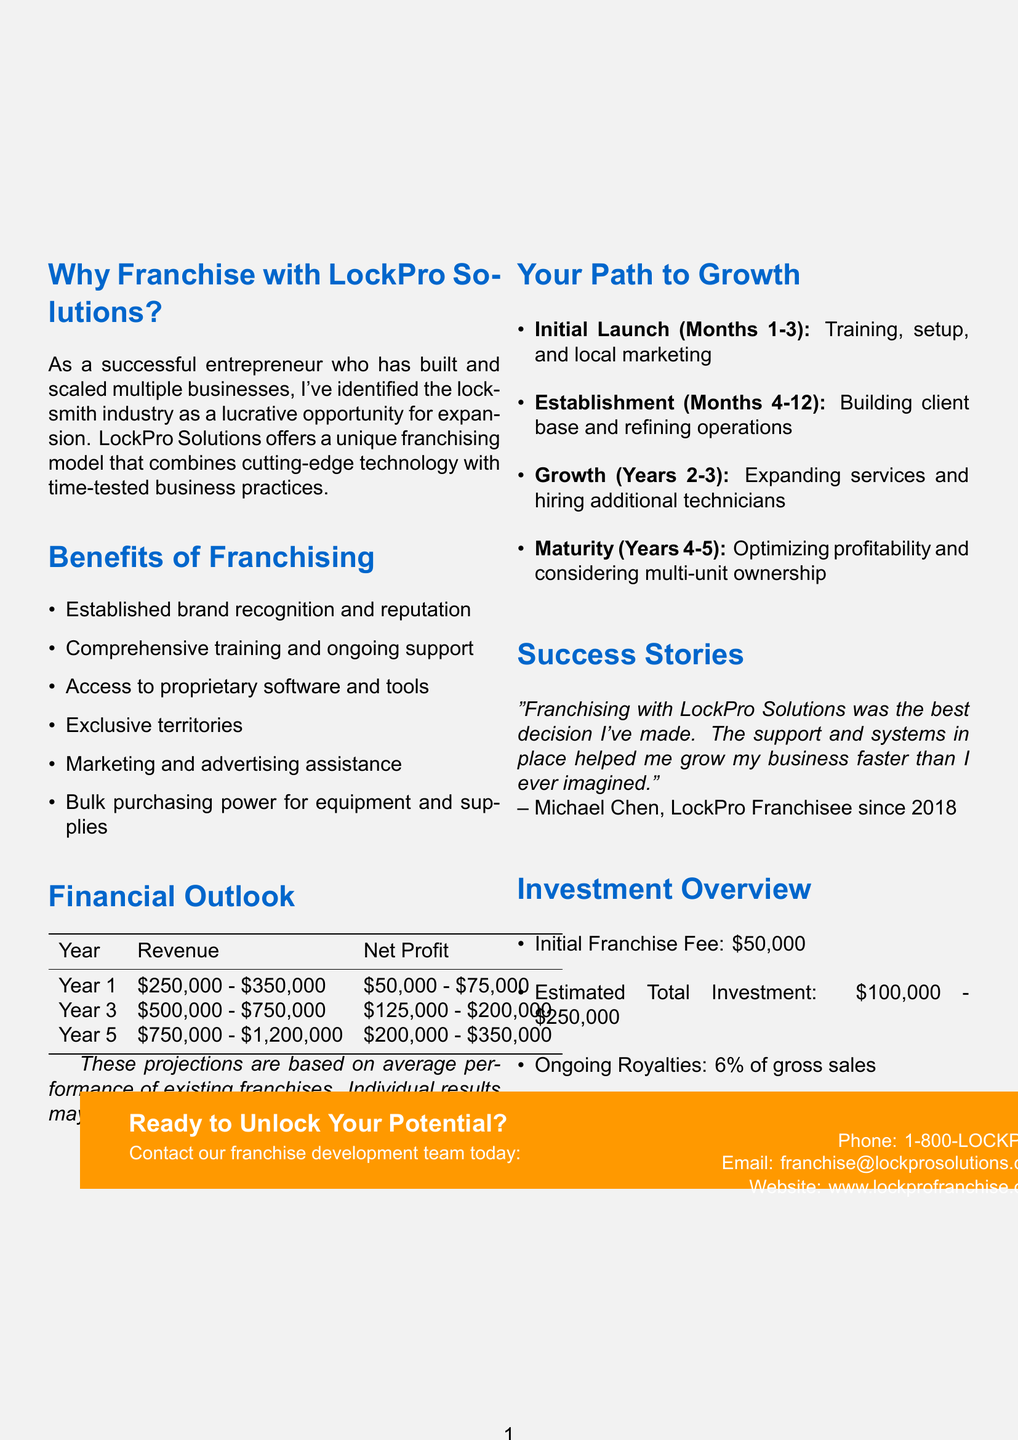What is the title of the brochure? The title of the brochure is clearly mentioned at the beginning of the document.
Answer: Unlocking Success: Franchise Your Locksmith Business What is the initial franchise fee? The initial franchise fee is stated in the investment overview section of the document.
Answer: $50,000 How long is the initial launch phase? This information can be found in the expansion timeline section of the document outlining the duration of phases.
Answer: Months 1-3 What is the estimated total investment range? The estimated total investment is listed in the investment overview section of the brochure.
Answer: $100,000 - $250,000 What percentage of gross sales is charged as ongoing royalties? This detail is provided in the investment overview section regarding ongoing costs.
Answer: 6% In which year does the revenue projection reach $500,000? Revenue projections are detailed with specific year references, allowing for this calculation.
Answer: Year 3 What support is provided as part of the franchising benefits? The benefits section lists various types of support available to franchisees.
Answer: Comprehensive training and ongoing support Who is the author of the testimonial? The testimonial section includes a quote and the name of the individual who provided it.
Answer: Michael Chen What is the marketing fee percentage? The marketing fee percentage is highlighted in the investment overview section detailing ongoing costs.
Answer: 2% 